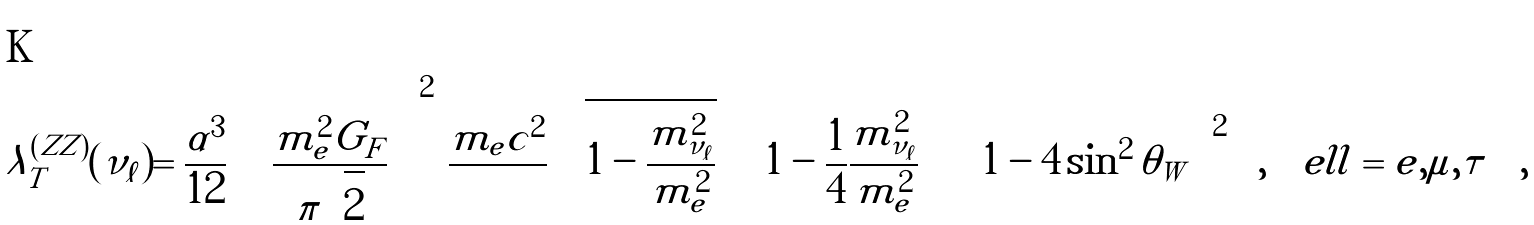<formula> <loc_0><loc_0><loc_500><loc_500>\lambda _ { T } ^ { ( Z Z ) } ( \nu _ { \ell } ) = \frac { \alpha ^ { 3 } } { 1 2 } \, \left ( \frac { m _ { e } ^ { 2 } G _ { F } } { \pi \sqrt { 2 } } \right ) ^ { 2 } \, \frac { m _ { e } c ^ { 2 } } { } \, \sqrt { 1 - \frac { m _ { \nu _ { \ell } } ^ { 2 } } { m _ { e } ^ { 2 } } } \ \left ( \, 1 - \frac { 1 } { 4 } \frac { m _ { \nu _ { \ell } } ^ { 2 } } { m _ { e } ^ { 2 } } \right ) \, \left ( \, 1 - 4 \sin ^ { 2 } \theta _ { W } \, \right ) ^ { 2 } \ \ , \quad e l l = e , \mu , \tau \quad ,</formula> 